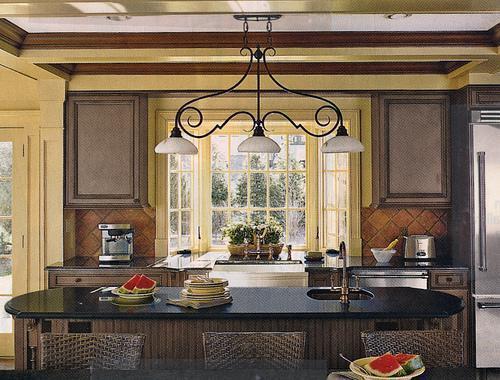In which one of these months do people like to eat this fruit?
Pick the right solution, then justify: 'Answer: answer
Rationale: rationale.'
Options: December, july, october, april. Answer: july.
Rationale: The people are eating water melon in july because it is the time of year where we pick it 